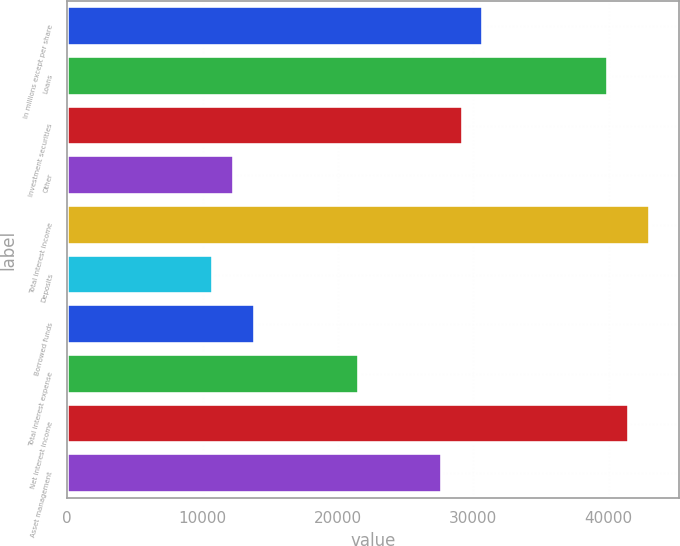<chart> <loc_0><loc_0><loc_500><loc_500><bar_chart><fcel>In millions except per share<fcel>Loans<fcel>Investment securities<fcel>Other<fcel>Total interest income<fcel>Deposits<fcel>Borrowed funds<fcel>Total interest expense<fcel>Net interest income<fcel>Asset management<nl><fcel>30745<fcel>39967<fcel>29208<fcel>12301<fcel>43041<fcel>10764<fcel>13838<fcel>21523<fcel>41504<fcel>27671<nl></chart> 